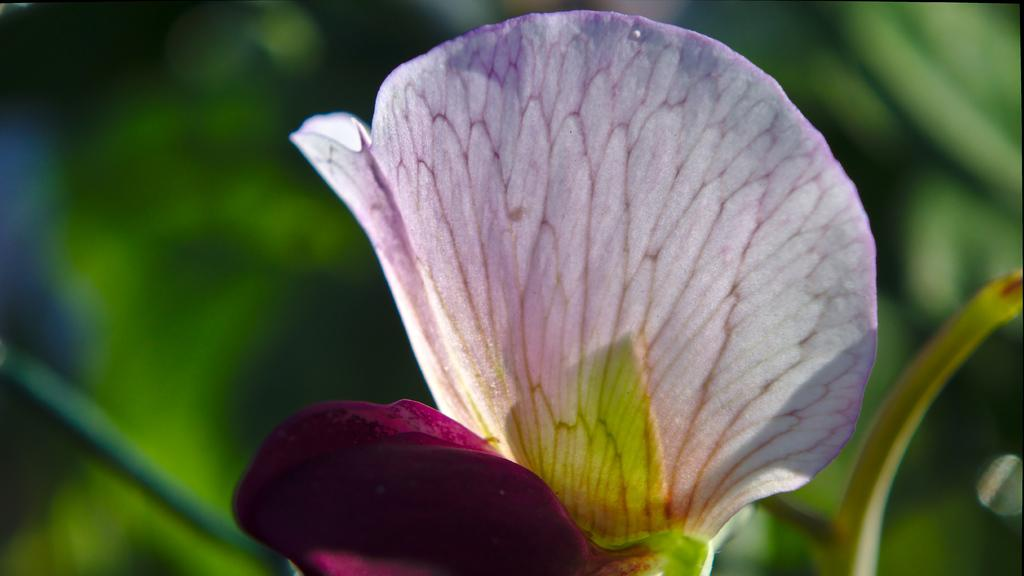What is the main subject in the foreground of the image? There is a flower in the foreground of the image. What can be seen in the background of the image? There are plants in the background of the image. How many women are visible in the image? There are no women present in the image; it features a flower and plants. Is there a ghost visible in the image? There is no ghost present in the image; it features a flower and plants. 